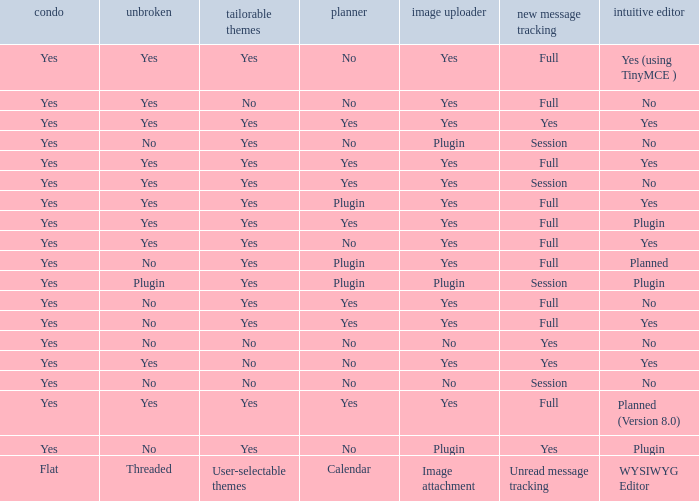Which Calendar has WYSIWYG Editor of yes and an Unread message tracking of yes? Yes, No. 